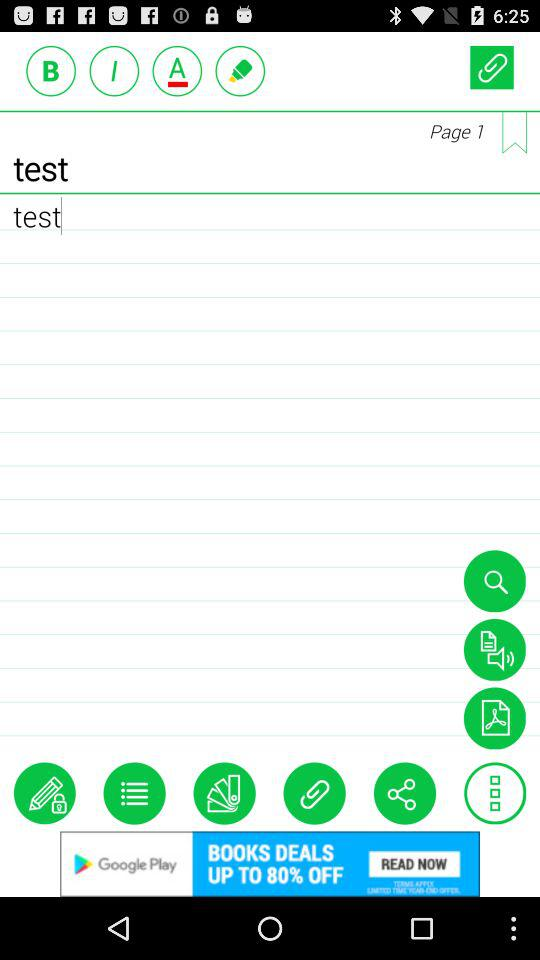What is the text entered in the text input? The entered text is "test". 